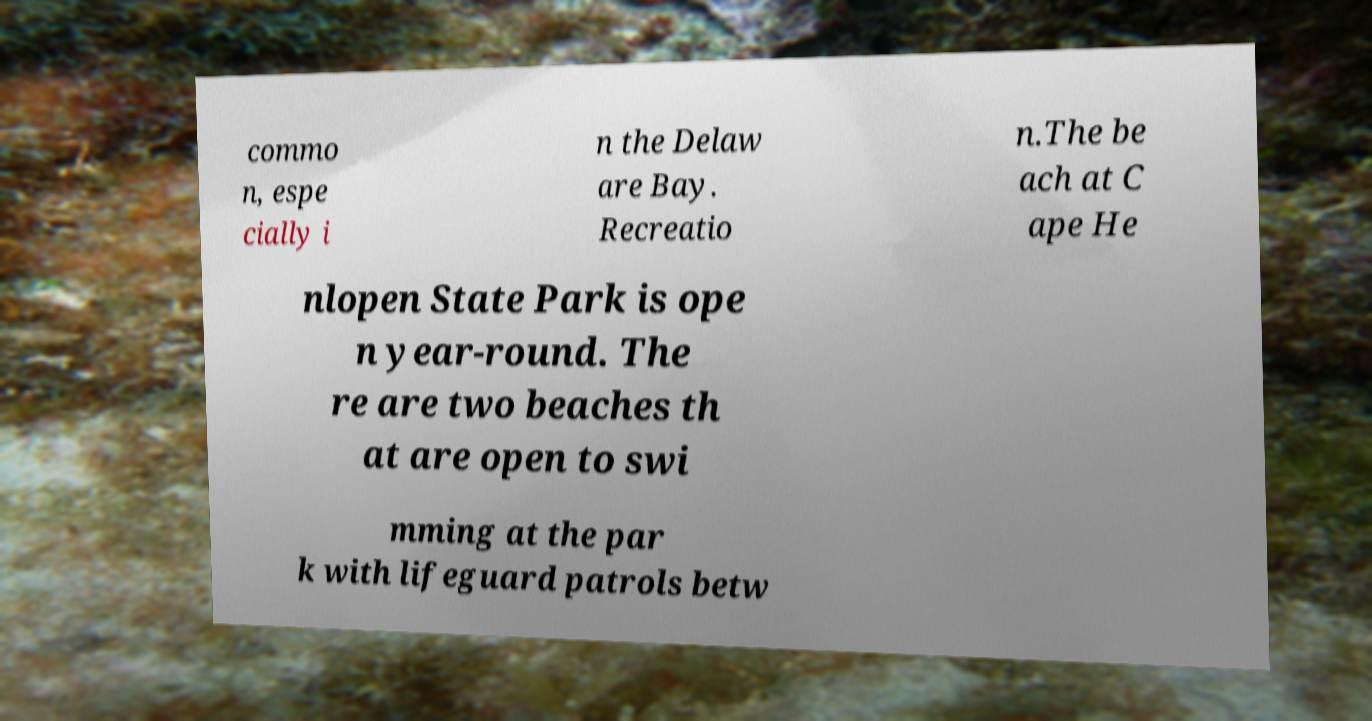Please read and relay the text visible in this image. What does it say? commo n, espe cially i n the Delaw are Bay. Recreatio n.The be ach at C ape He nlopen State Park is ope n year-round. The re are two beaches th at are open to swi mming at the par k with lifeguard patrols betw 